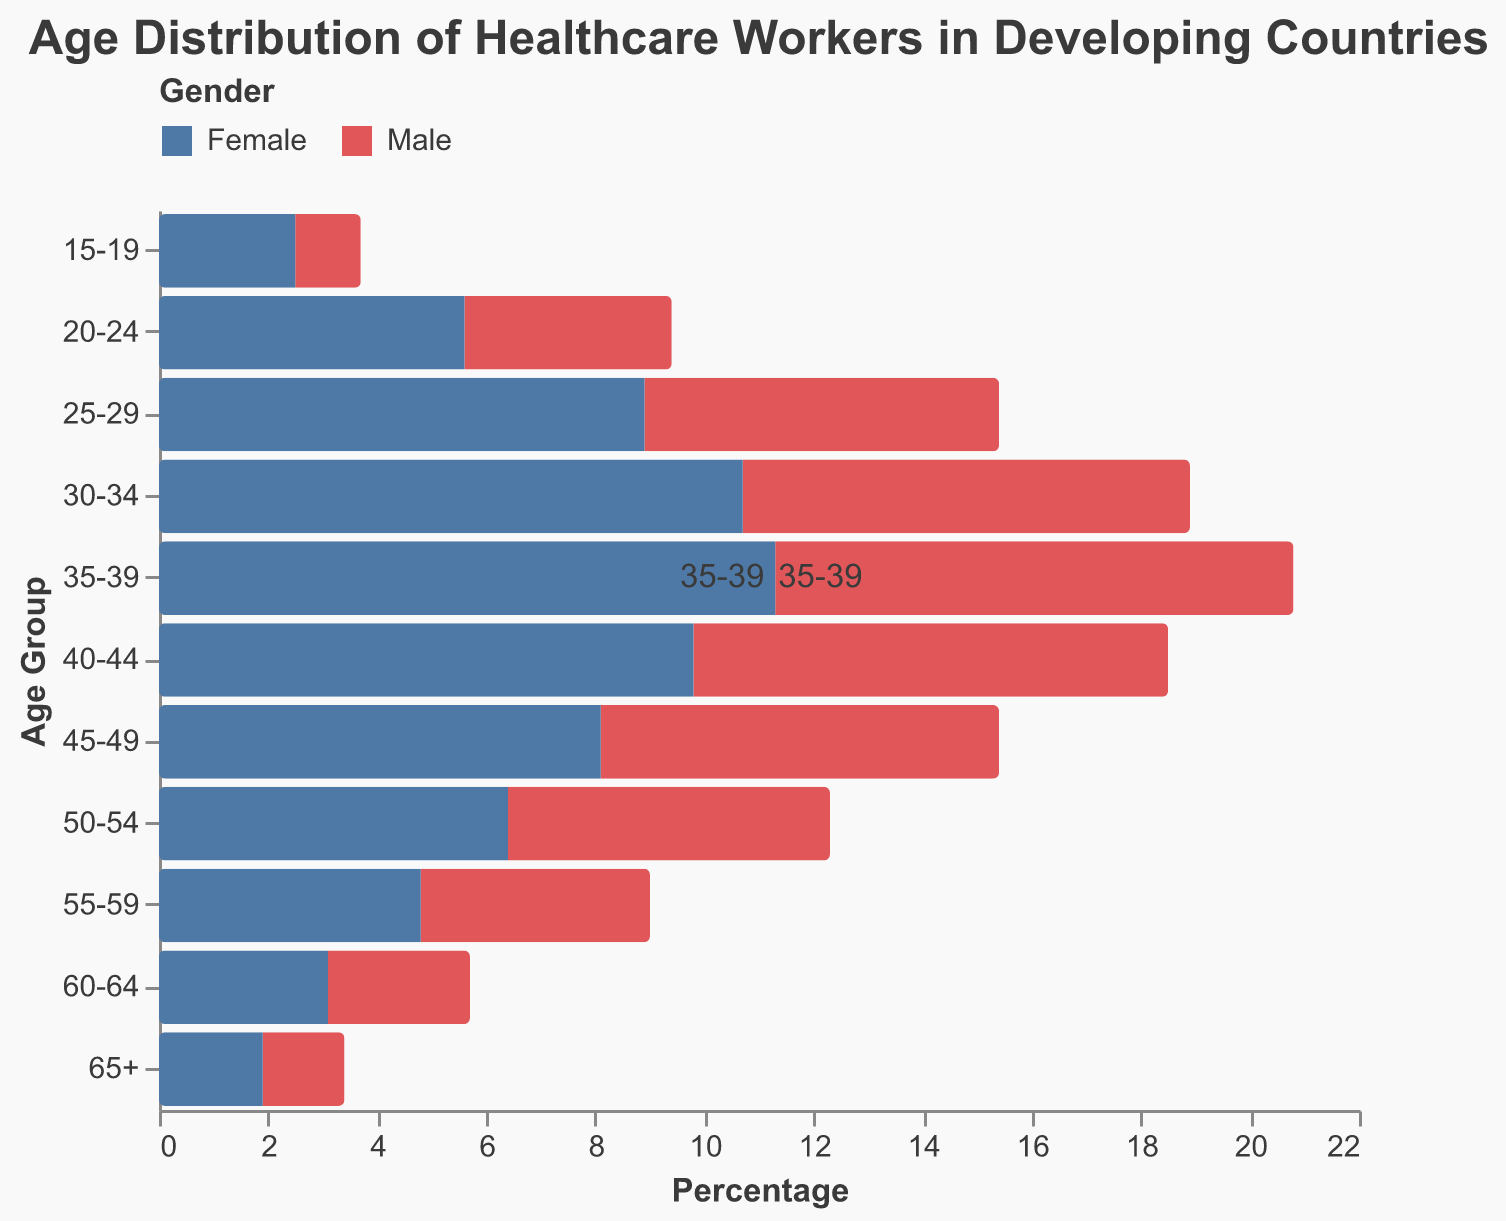What is the age group with the highest percentage of female healthcare workers? By looking at the tallest red bar, we can see that the age group 35-39 has the highest percentage of female healthcare workers, indicated by the 11.3% value for the Female category.
Answer: 35-39 What is the difference in percentage between male and female healthcare workers in the 25-29 age group? The percentage of female healthcare workers in the 25-29 age group is 8.9%, and the percentage of male healthcare workers is 6.5%. The difference is calculated as 8.9% - 6.5% = 2.4%.
Answer: 2.4% Which gender has more healthcare workers aged 60-64? By comparing the heights of the bars, for the age group 60-64, the female percentage (3.1%) is greater than the male percentage (2.6%). Thus, there are more female healthcare workers in this age group.
Answer: Female How does the percentage of male healthcare workers aged 40-44 compare to those aged 45-49? The percentage of male healthcare workers aged 40-44 is 8.7%, and for those aged 45-49, it is 7.3%. Comparing these values, 8.7% is greater than 7.3%.
Answer: 8.7% is greater Which age group shows the least percentage of healthcare workers for both genders? The smallest values in both male (-1.2%) and female (2.5%) categories are found in the age group 15-19, so this group has the least percentage of healthcare workers for both genders.
Answer: 15-19 What is the total percentage of all healthcare workers in the age group 30-34? To find the total percentage, we add the male percentage (8.2%) to the female percentage (10.7%) of the age group 30-34, which results in 8.2% + 10.7% = 18.9%.
Answer: 18.9% How does the population distribution for female healthcare workers change as they age from 20-24 to 40-44? The percentages for females in these age groups are: 20-24 (5.6%), 25-29 (8.9%), 30-34 (10.7%), 35-39 (11.3%), and 40-44 (9.8%). There is an increasing trend from 20-24 to 35-39, followed by a slight decline in 40-44.
Answer: Increases then slightly decreases Among healthcare workers aged 55-59, which gender has a higher percentage, and by how much? The percentage of female healthcare workers in the 55-59 age group is 4.8%, and the percentage of male healthcare workers is 4.2%. The difference is 4.8% - 4.2% = 0.6%, indicating that females have a higher percentage.
Answer: Female, by 0.6% In which age group is the gender disparity most noticeable, and what is the difference? The age group with the largest difference between male and female percentages is 35-39, with male as 9.5% and female as 11.3%. The disparity is 11.3% - 9.5% = 1.8%.
Answer: 35-39, 1.8% Looking at the age groups 45-49 and 50-54, what trends can be observed in the percentages of both genders? For females, the percentages decrease from 8.1% to 6.4% as we move from the age group 45-49 to 50-54. For males, the percentages also decrease from 7.3% to 5.9%. The trend for both genders is a decline.
Answer: Decreasing trend 